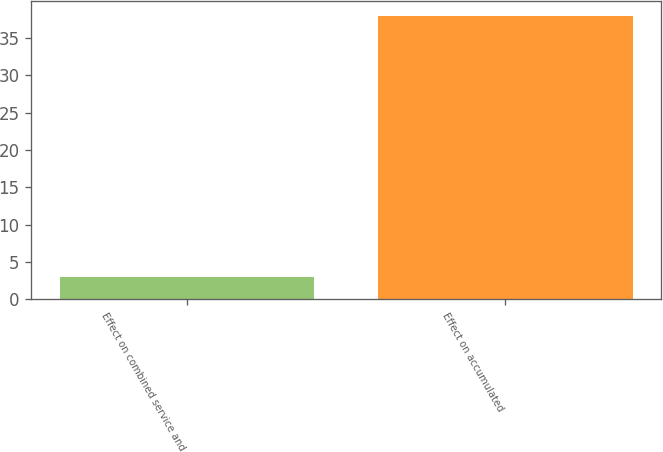<chart> <loc_0><loc_0><loc_500><loc_500><bar_chart><fcel>Effect on combined service and<fcel>Effect on accumulated<nl><fcel>3<fcel>38<nl></chart> 